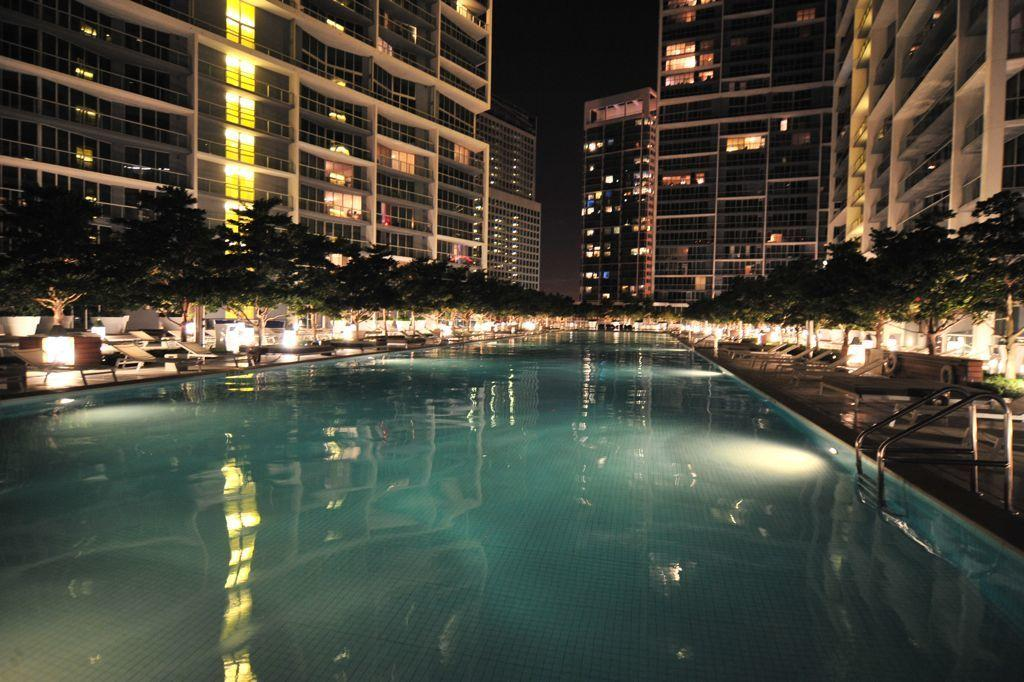What is the main feature of the picture? There is a swimming pool in the picture. What other objects can be seen in the picture? There are chairs, trees, lights, and buildings in the picture. Can you describe the buildings in the picture? The buildings have glass windows. What is the condition of the sky in the picture? The sky is dark in the picture. What type of blade is being used by the person in the picture? There is no person visible in the image, and therefore no blade can be observed. Is there a crown visible on anyone's head in the picture? No, there is no crown present in the image. 